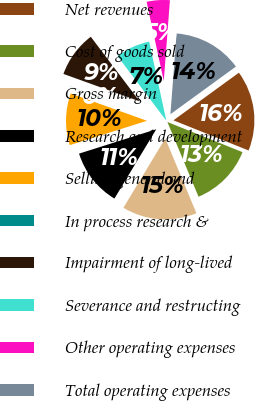Convert chart to OTSL. <chart><loc_0><loc_0><loc_500><loc_500><pie_chart><fcel>Net revenues<fcel>Cost of goods sold<fcel>Gross margin<fcel>Research and development<fcel>Selling general and<fcel>In process research &<fcel>Impairment of long-lived<fcel>Severance and restructing<fcel>Other operating expenses<fcel>Total operating expenses<nl><fcel>16.08%<fcel>12.64%<fcel>14.93%<fcel>11.49%<fcel>10.34%<fcel>0.02%<fcel>9.2%<fcel>6.9%<fcel>4.61%<fcel>13.78%<nl></chart> 